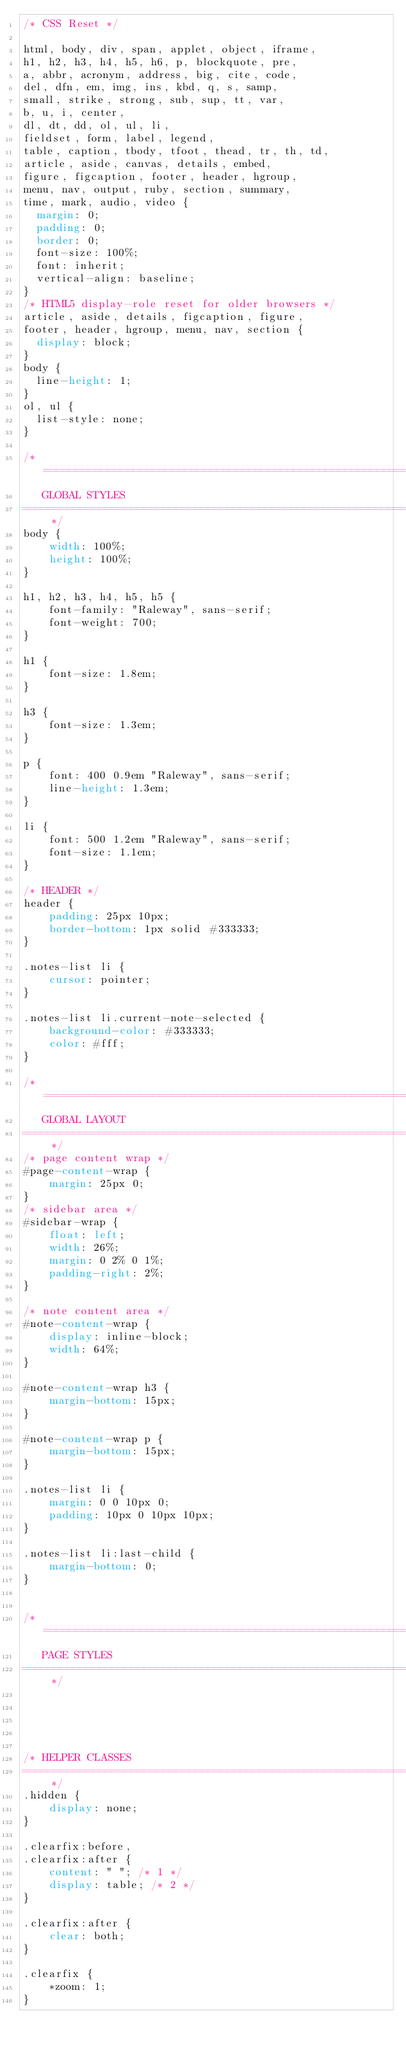<code> <loc_0><loc_0><loc_500><loc_500><_CSS_>/* CSS Reset */

html, body, div, span, applet, object, iframe,
h1, h2, h3, h4, h5, h6, p, blockquote, pre,
a, abbr, acronym, address, big, cite, code,
del, dfn, em, img, ins, kbd, q, s, samp,
small, strike, strong, sub, sup, tt, var,
b, u, i, center,
dl, dt, dd, ol, ul, li,
fieldset, form, label, legend,
table, caption, tbody, tfoot, thead, tr, th, td,
article, aside, canvas, details, embed, 
figure, figcaption, footer, header, hgroup, 
menu, nav, output, ruby, section, summary,
time, mark, audio, video {
	margin: 0;
	padding: 0;
	border: 0;
	font-size: 100%;
	font: inherit;
	vertical-align: baseline;
}
/* HTML5 display-role reset for older browsers */
article, aside, details, figcaption, figure, 
footer, header, hgroup, menu, nav, section {
	display: block;
}
body {
	line-height: 1;
}
ol, ul {
	list-style: none;
}

/* =======================================================================
   GLOBAL STYLES   
========================================================================== */
body {
    width: 100%;
    height: 100%;
}

h1, h2, h3, h4, h5, h5 {
    font-family: "Raleway", sans-serif;    
    font-weight: 700;
}

h1 {
    font-size: 1.8em;
}

h3 {
    font-size: 1.3em;
}

p {
    font: 400 0.9em "Raleway", sans-serif;
    line-height: 1.3em;
}

li {
    font: 500 1.2em "Raleway", sans-serif;
    font-size: 1.1em;
}

/* HEADER */
header {
    padding: 25px 10px;
    border-bottom: 1px solid #333333;
}

.notes-list li {
    cursor: pointer;
}

.notes-list li.current-note-selected {
    background-color: #333333;
    color: #fff;
}

/* =======================================================================
   GLOBAL LAYOUT   
========================================================================== */
/* page content wrap */
#page-content-wrap {
    margin: 25px 0;
}
/* sidebar area */
#sidebar-wrap {
    float: left;
    width: 26%;
    margin: 0 2% 0 1%;
    padding-right: 2%;
}

/* note content area */            
#note-content-wrap {
    display: inline-block;
    width: 64%;
}

#note-content-wrap h3 {
    margin-bottom: 15px;
}

#note-content-wrap p {
    margin-bottom: 15px;
}

.notes-list li {
    margin: 0 0 10px 0;    
    padding: 10px 0 10px 10px;       
}

.notes-list li:last-child {
    margin-bottom: 0;
}


/* =======================================================================
   PAGE STYLES   
========================================================================== */





/* HELPER CLASSES
====================================================================== */
.hidden {
    display: none;
}

.clearfix:before,
.clearfix:after {
    content: " "; /* 1 */
    display: table; /* 2 */
}

.clearfix:after {
    clear: both;
}

.clearfix {
    *zoom: 1;
}


</code> 